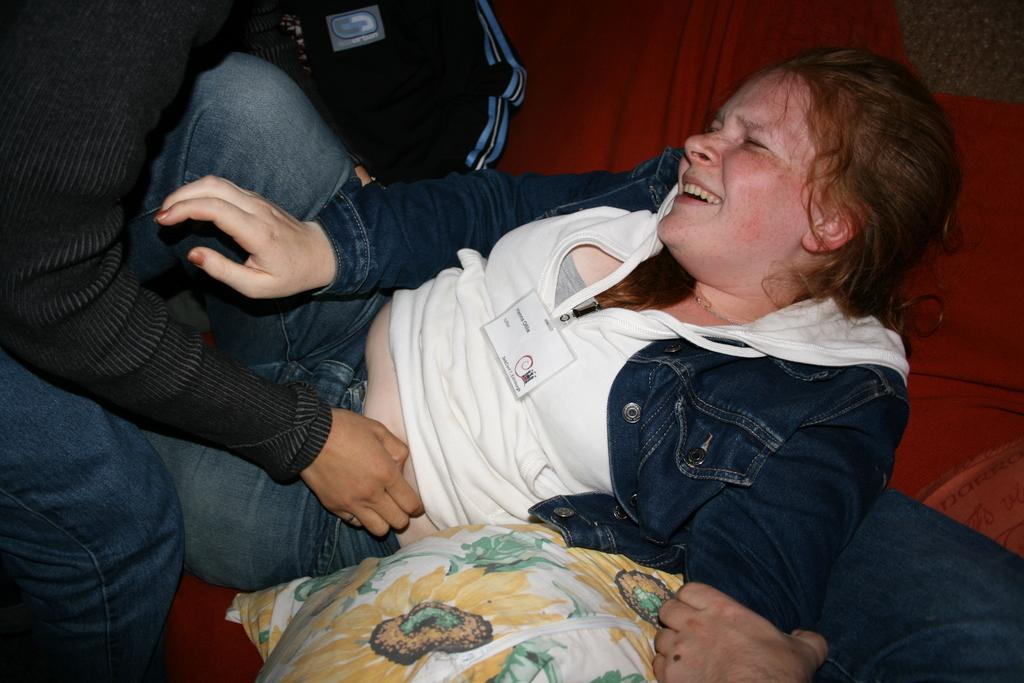Who is the main subject in the image? There is a girl in the image. What is the girl wearing? The girl is wearing a white hoodie and a blue jacket. Where is the girl located in the image? The girl is laying on a bed. What can be seen on the bed besides the girl? There is a floral pillow on the bed. Who else is present in the image? There is another person in the image. What is the other person doing to the girl? The other person is gagging the girl on the stomach. What type of rifle can be seen in the girl's hand in the image? There is no rifle present in the image; the girl is not holding any object in her hand. 